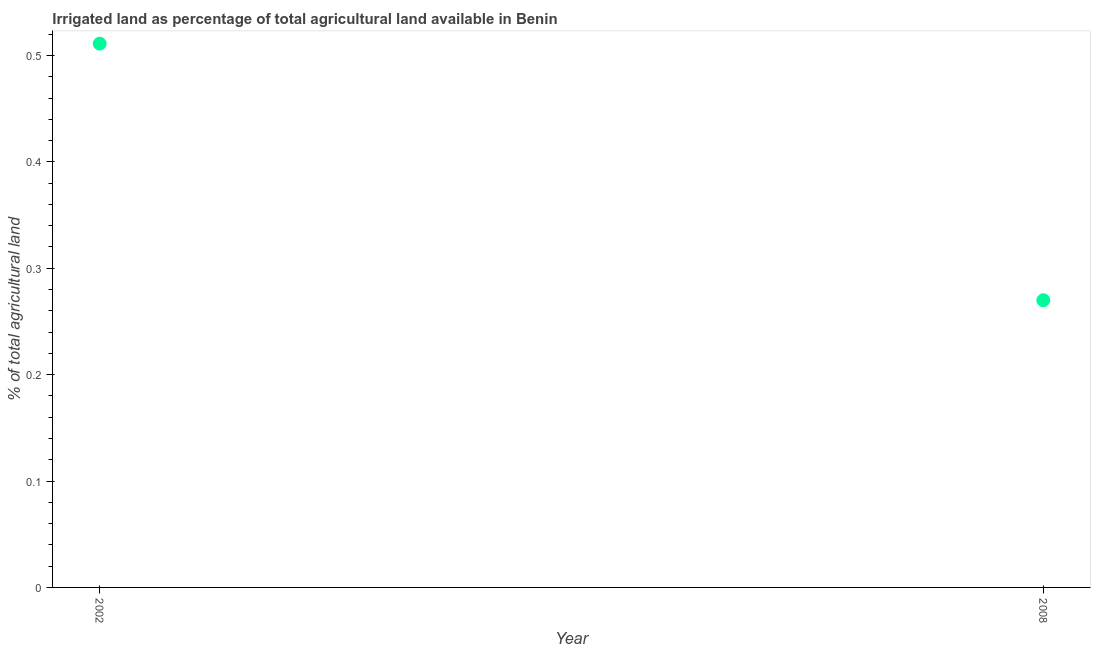What is the percentage of agricultural irrigated land in 2002?
Give a very brief answer. 0.51. Across all years, what is the maximum percentage of agricultural irrigated land?
Your response must be concise. 0.51. Across all years, what is the minimum percentage of agricultural irrigated land?
Ensure brevity in your answer.  0.27. What is the sum of the percentage of agricultural irrigated land?
Your answer should be very brief. 0.78. What is the difference between the percentage of agricultural irrigated land in 2002 and 2008?
Give a very brief answer. 0.24. What is the average percentage of agricultural irrigated land per year?
Your answer should be very brief. 0.39. What is the median percentage of agricultural irrigated land?
Ensure brevity in your answer.  0.39. What is the ratio of the percentage of agricultural irrigated land in 2002 to that in 2008?
Offer a very short reply. 1.89. Is the percentage of agricultural irrigated land in 2002 less than that in 2008?
Offer a very short reply. No. How many dotlines are there?
Keep it short and to the point. 1. How many years are there in the graph?
Keep it short and to the point. 2. What is the difference between two consecutive major ticks on the Y-axis?
Offer a terse response. 0.1. What is the title of the graph?
Give a very brief answer. Irrigated land as percentage of total agricultural land available in Benin. What is the label or title of the X-axis?
Your response must be concise. Year. What is the label or title of the Y-axis?
Provide a succinct answer. % of total agricultural land. What is the % of total agricultural land in 2002?
Make the answer very short. 0.51. What is the % of total agricultural land in 2008?
Keep it short and to the point. 0.27. What is the difference between the % of total agricultural land in 2002 and 2008?
Give a very brief answer. 0.24. What is the ratio of the % of total agricultural land in 2002 to that in 2008?
Ensure brevity in your answer.  1.89. 